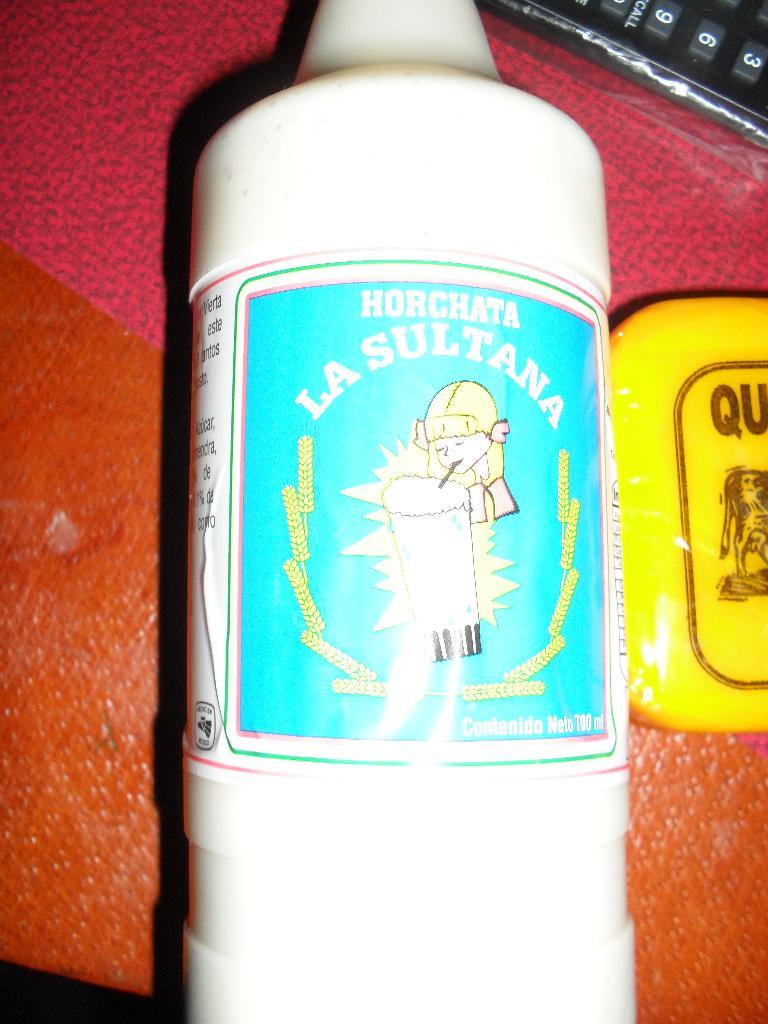What type of drink is in this bottle?
Make the answer very short. Horchata. 